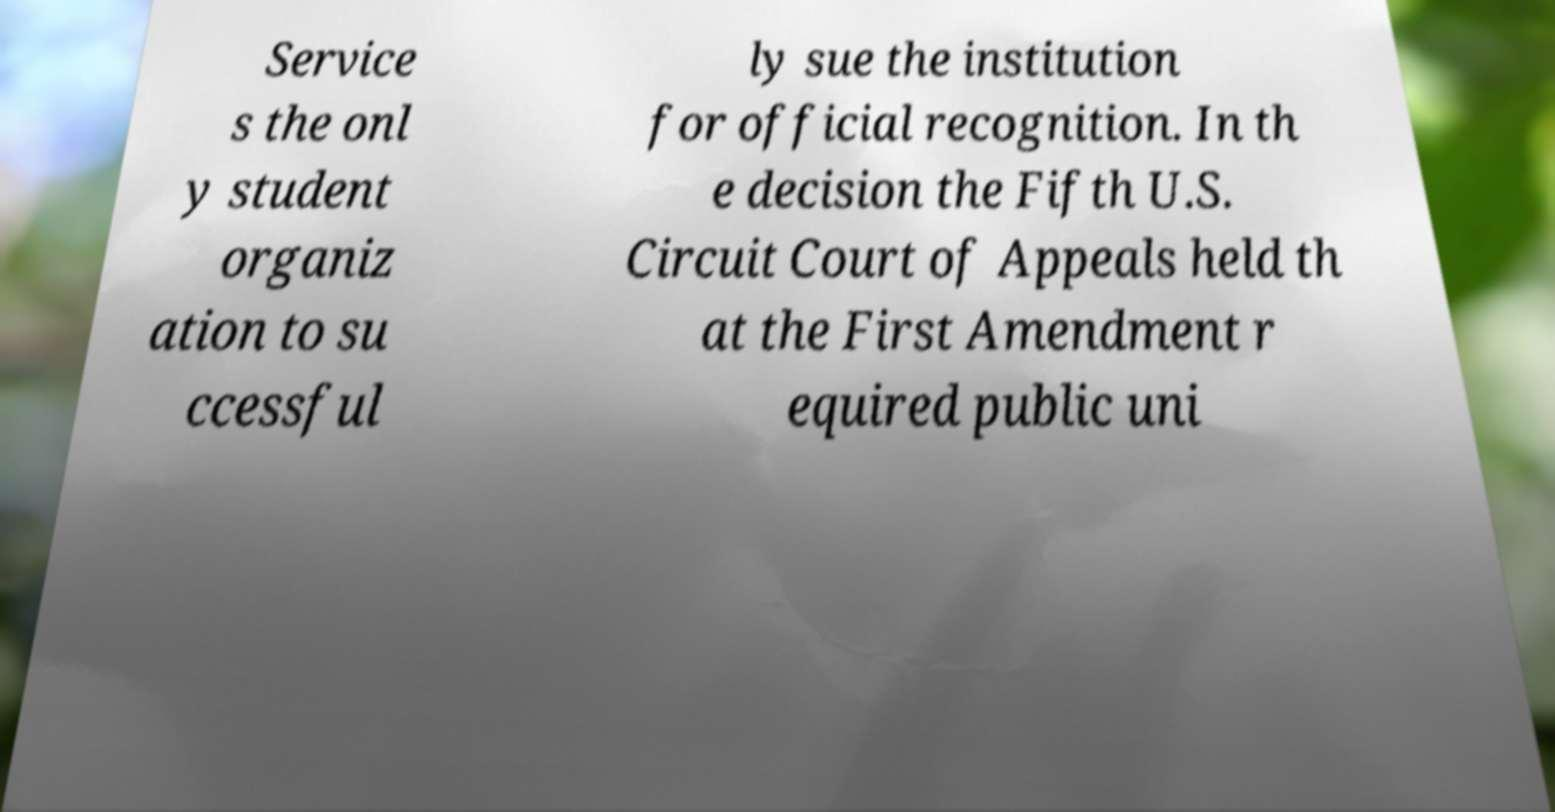What messages or text are displayed in this image? I need them in a readable, typed format. Service s the onl y student organiz ation to su ccessful ly sue the institution for official recognition. In th e decision the Fifth U.S. Circuit Court of Appeals held th at the First Amendment r equired public uni 